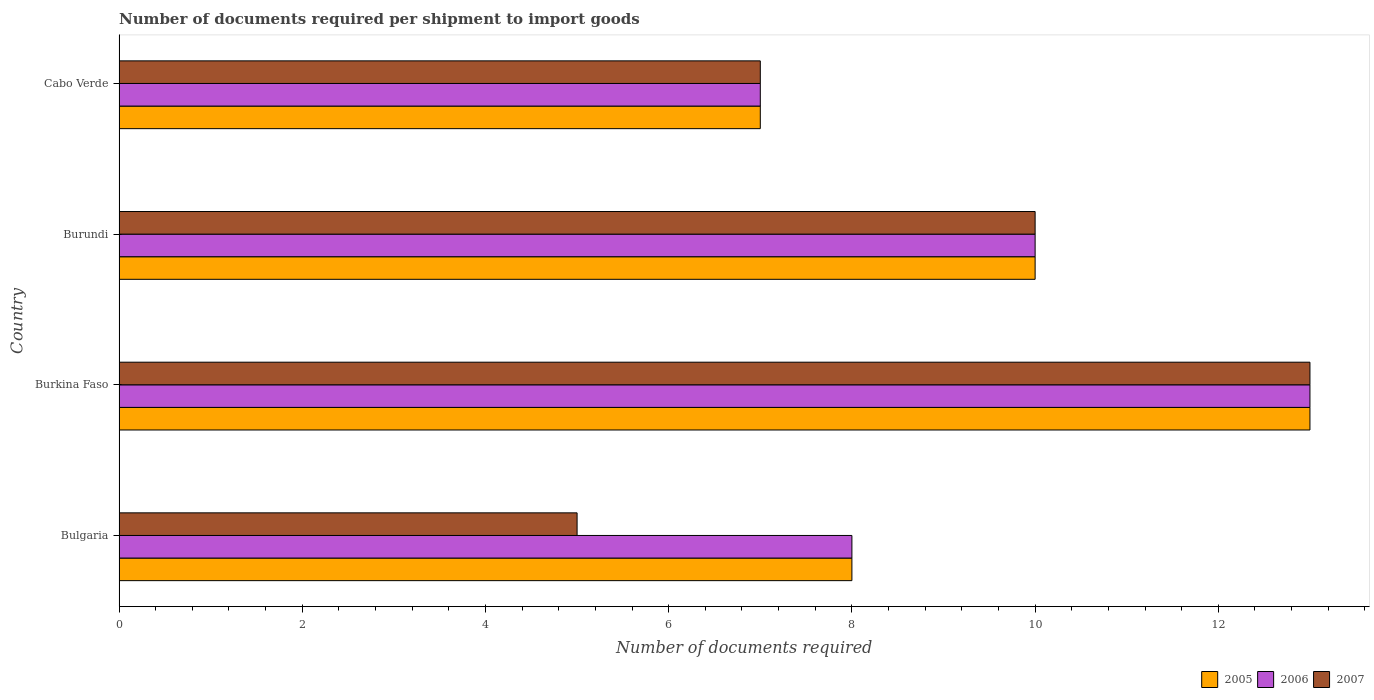How many different coloured bars are there?
Provide a succinct answer. 3. How many groups of bars are there?
Offer a very short reply. 4. Are the number of bars per tick equal to the number of legend labels?
Your response must be concise. Yes. Are the number of bars on each tick of the Y-axis equal?
Your answer should be very brief. Yes. How many bars are there on the 3rd tick from the top?
Provide a succinct answer. 3. How many bars are there on the 2nd tick from the bottom?
Give a very brief answer. 3. What is the label of the 1st group of bars from the top?
Offer a terse response. Cabo Verde. In how many cases, is the number of bars for a given country not equal to the number of legend labels?
Your response must be concise. 0. What is the number of documents required per shipment to import goods in 2005 in Burkina Faso?
Make the answer very short. 13. Across all countries, what is the maximum number of documents required per shipment to import goods in 2006?
Your answer should be compact. 13. In which country was the number of documents required per shipment to import goods in 2007 maximum?
Provide a succinct answer. Burkina Faso. In which country was the number of documents required per shipment to import goods in 2005 minimum?
Ensure brevity in your answer.  Cabo Verde. What is the difference between the number of documents required per shipment to import goods in 2006 in Burundi and that in Cabo Verde?
Make the answer very short. 3. What is the average number of documents required per shipment to import goods in 2007 per country?
Your answer should be compact. 8.75. What is the ratio of the number of documents required per shipment to import goods in 2006 in Burkina Faso to that in Cabo Verde?
Your answer should be very brief. 1.86. Is the difference between the number of documents required per shipment to import goods in 2007 in Bulgaria and Burundi greater than the difference between the number of documents required per shipment to import goods in 2005 in Bulgaria and Burundi?
Keep it short and to the point. No. What is the difference between the highest and the second highest number of documents required per shipment to import goods in 2007?
Your answer should be compact. 3. What is the difference between the highest and the lowest number of documents required per shipment to import goods in 2007?
Provide a short and direct response. 8. What does the 1st bar from the bottom in Cabo Verde represents?
Your response must be concise. 2005. Is it the case that in every country, the sum of the number of documents required per shipment to import goods in 2006 and number of documents required per shipment to import goods in 2005 is greater than the number of documents required per shipment to import goods in 2007?
Your answer should be very brief. Yes. How many bars are there?
Your response must be concise. 12. What is the difference between two consecutive major ticks on the X-axis?
Provide a short and direct response. 2. Are the values on the major ticks of X-axis written in scientific E-notation?
Offer a terse response. No. Does the graph contain any zero values?
Ensure brevity in your answer.  No. Does the graph contain grids?
Ensure brevity in your answer.  No. Where does the legend appear in the graph?
Keep it short and to the point. Bottom right. How are the legend labels stacked?
Provide a succinct answer. Horizontal. What is the title of the graph?
Keep it short and to the point. Number of documents required per shipment to import goods. What is the label or title of the X-axis?
Offer a very short reply. Number of documents required. What is the Number of documents required of 2006 in Bulgaria?
Provide a succinct answer. 8. What is the Number of documents required in 2006 in Burkina Faso?
Offer a very short reply. 13. What is the Number of documents required in 2007 in Burkina Faso?
Provide a succinct answer. 13. What is the Number of documents required in 2005 in Burundi?
Give a very brief answer. 10. What is the Number of documents required of 2006 in Burundi?
Ensure brevity in your answer.  10. What is the Number of documents required of 2005 in Cabo Verde?
Your answer should be compact. 7. Across all countries, what is the maximum Number of documents required in 2005?
Offer a very short reply. 13. Across all countries, what is the maximum Number of documents required in 2007?
Offer a terse response. 13. Across all countries, what is the minimum Number of documents required in 2005?
Offer a very short reply. 7. What is the total Number of documents required of 2005 in the graph?
Keep it short and to the point. 38. What is the difference between the Number of documents required of 2005 in Bulgaria and that in Burkina Faso?
Your response must be concise. -5. What is the difference between the Number of documents required of 2007 in Bulgaria and that in Burkina Faso?
Provide a succinct answer. -8. What is the difference between the Number of documents required in 2005 in Bulgaria and that in Burundi?
Provide a short and direct response. -2. What is the difference between the Number of documents required of 2007 in Bulgaria and that in Burundi?
Provide a short and direct response. -5. What is the difference between the Number of documents required in 2005 in Bulgaria and that in Cabo Verde?
Your response must be concise. 1. What is the difference between the Number of documents required in 2006 in Bulgaria and that in Cabo Verde?
Offer a terse response. 1. What is the difference between the Number of documents required of 2007 in Bulgaria and that in Cabo Verde?
Offer a terse response. -2. What is the difference between the Number of documents required of 2007 in Burkina Faso and that in Burundi?
Offer a very short reply. 3. What is the difference between the Number of documents required in 2005 in Burkina Faso and that in Cabo Verde?
Your answer should be compact. 6. What is the difference between the Number of documents required of 2006 in Burkina Faso and that in Cabo Verde?
Provide a succinct answer. 6. What is the difference between the Number of documents required of 2006 in Burundi and that in Cabo Verde?
Keep it short and to the point. 3. What is the difference between the Number of documents required of 2005 in Bulgaria and the Number of documents required of 2006 in Burkina Faso?
Provide a short and direct response. -5. What is the difference between the Number of documents required in 2005 in Bulgaria and the Number of documents required in 2007 in Burkina Faso?
Offer a terse response. -5. What is the difference between the Number of documents required of 2006 in Bulgaria and the Number of documents required of 2007 in Burkina Faso?
Keep it short and to the point. -5. What is the difference between the Number of documents required in 2005 in Bulgaria and the Number of documents required in 2006 in Burundi?
Your response must be concise. -2. What is the difference between the Number of documents required of 2005 in Bulgaria and the Number of documents required of 2007 in Burundi?
Ensure brevity in your answer.  -2. What is the difference between the Number of documents required of 2006 in Bulgaria and the Number of documents required of 2007 in Burundi?
Make the answer very short. -2. What is the difference between the Number of documents required in 2005 in Bulgaria and the Number of documents required in 2007 in Cabo Verde?
Your response must be concise. 1. What is the difference between the Number of documents required in 2005 in Burkina Faso and the Number of documents required in 2006 in Burundi?
Ensure brevity in your answer.  3. What is the difference between the Number of documents required of 2005 in Burkina Faso and the Number of documents required of 2007 in Burundi?
Ensure brevity in your answer.  3. What is the difference between the Number of documents required in 2006 in Burkina Faso and the Number of documents required in 2007 in Burundi?
Make the answer very short. 3. What is the difference between the Number of documents required in 2005 in Burkina Faso and the Number of documents required in 2007 in Cabo Verde?
Keep it short and to the point. 6. What is the difference between the Number of documents required in 2006 in Burkina Faso and the Number of documents required in 2007 in Cabo Verde?
Make the answer very short. 6. What is the difference between the Number of documents required in 2005 in Burundi and the Number of documents required in 2006 in Cabo Verde?
Provide a short and direct response. 3. What is the difference between the Number of documents required of 2006 in Burundi and the Number of documents required of 2007 in Cabo Verde?
Your response must be concise. 3. What is the average Number of documents required of 2005 per country?
Keep it short and to the point. 9.5. What is the average Number of documents required of 2007 per country?
Give a very brief answer. 8.75. What is the difference between the Number of documents required of 2005 and Number of documents required of 2006 in Bulgaria?
Provide a succinct answer. 0. What is the difference between the Number of documents required of 2005 and Number of documents required of 2007 in Bulgaria?
Ensure brevity in your answer.  3. What is the difference between the Number of documents required in 2006 and Number of documents required in 2007 in Bulgaria?
Offer a very short reply. 3. What is the difference between the Number of documents required of 2005 and Number of documents required of 2007 in Burkina Faso?
Your answer should be very brief. 0. What is the difference between the Number of documents required of 2005 and Number of documents required of 2007 in Burundi?
Provide a succinct answer. 0. What is the difference between the Number of documents required of 2005 and Number of documents required of 2007 in Cabo Verde?
Offer a terse response. 0. What is the ratio of the Number of documents required of 2005 in Bulgaria to that in Burkina Faso?
Your answer should be compact. 0.62. What is the ratio of the Number of documents required in 2006 in Bulgaria to that in Burkina Faso?
Your answer should be very brief. 0.62. What is the ratio of the Number of documents required of 2007 in Bulgaria to that in Burkina Faso?
Your answer should be very brief. 0.38. What is the ratio of the Number of documents required in 2005 in Bulgaria to that in Burundi?
Provide a short and direct response. 0.8. What is the ratio of the Number of documents required in 2006 in Bulgaria to that in Burundi?
Provide a succinct answer. 0.8. What is the ratio of the Number of documents required in 2005 in Bulgaria to that in Cabo Verde?
Your response must be concise. 1.14. What is the ratio of the Number of documents required of 2005 in Burkina Faso to that in Burundi?
Make the answer very short. 1.3. What is the ratio of the Number of documents required in 2006 in Burkina Faso to that in Burundi?
Make the answer very short. 1.3. What is the ratio of the Number of documents required in 2005 in Burkina Faso to that in Cabo Verde?
Your answer should be compact. 1.86. What is the ratio of the Number of documents required in 2006 in Burkina Faso to that in Cabo Verde?
Ensure brevity in your answer.  1.86. What is the ratio of the Number of documents required of 2007 in Burkina Faso to that in Cabo Verde?
Make the answer very short. 1.86. What is the ratio of the Number of documents required in 2005 in Burundi to that in Cabo Verde?
Provide a succinct answer. 1.43. What is the ratio of the Number of documents required in 2006 in Burundi to that in Cabo Verde?
Ensure brevity in your answer.  1.43. What is the ratio of the Number of documents required in 2007 in Burundi to that in Cabo Verde?
Provide a short and direct response. 1.43. What is the difference between the highest and the second highest Number of documents required in 2007?
Provide a succinct answer. 3. What is the difference between the highest and the lowest Number of documents required of 2005?
Offer a terse response. 6. 